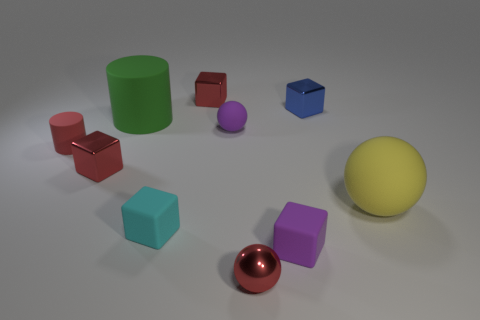Subtract 2 blocks. How many blocks are left? 3 Subtract all blue cubes. How many cubes are left? 4 Subtract all blue blocks. How many blocks are left? 4 Subtract all yellow blocks. Subtract all yellow balls. How many blocks are left? 5 Subtract all cylinders. How many objects are left? 8 Add 2 blue blocks. How many blue blocks are left? 3 Add 1 tiny blue objects. How many tiny blue objects exist? 2 Subtract 1 red cubes. How many objects are left? 9 Subtract all purple cylinders. Subtract all big green matte cylinders. How many objects are left? 9 